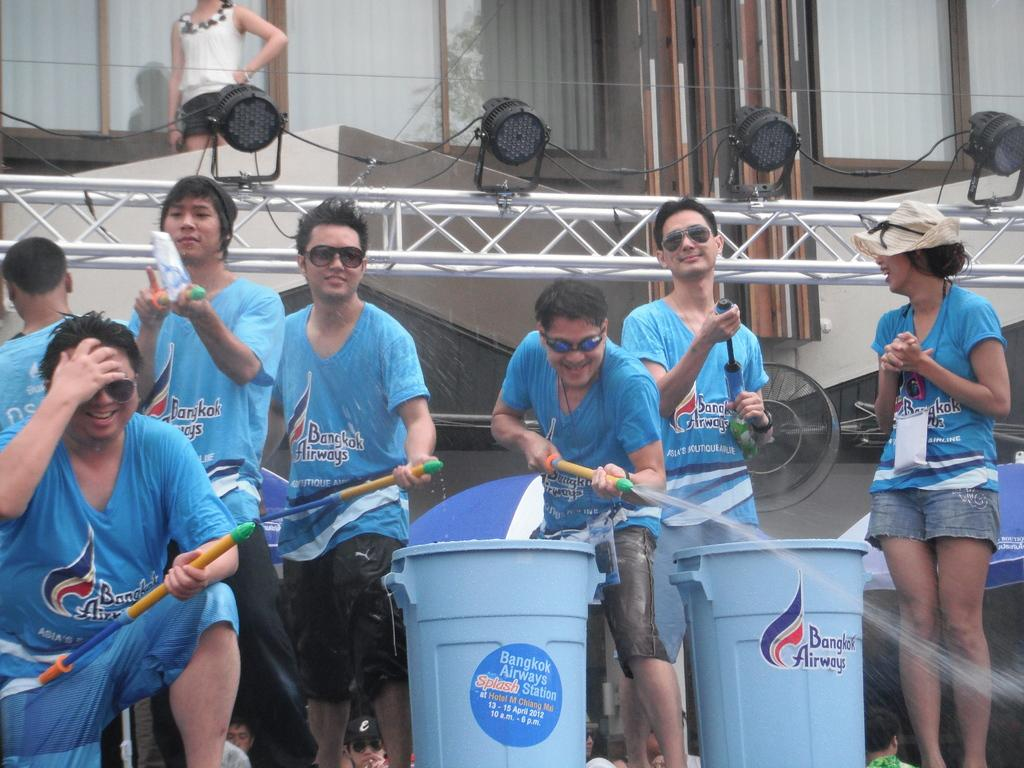<image>
Present a compact description of the photo's key features. A group of men with water hoses wearing blue Bangkok Airways shirts. 